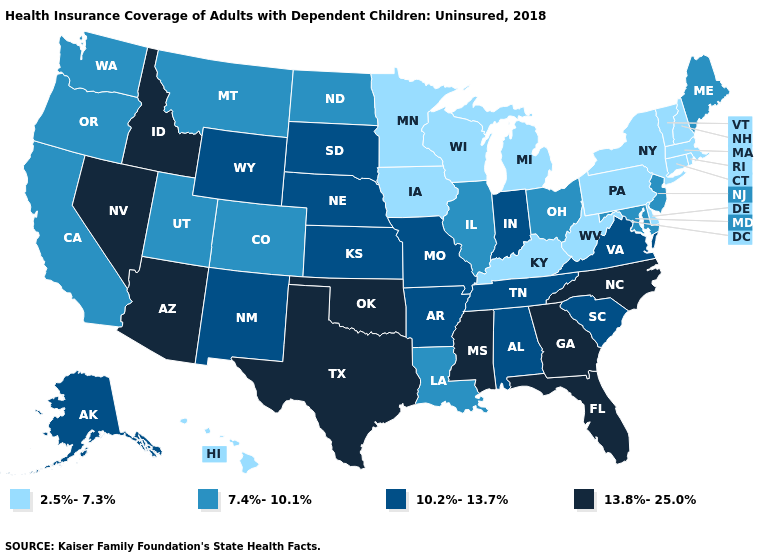Which states have the lowest value in the USA?
Write a very short answer. Connecticut, Delaware, Hawaii, Iowa, Kentucky, Massachusetts, Michigan, Minnesota, New Hampshire, New York, Pennsylvania, Rhode Island, Vermont, West Virginia, Wisconsin. Among the states that border Vermont , which have the highest value?
Be succinct. Massachusetts, New Hampshire, New York. What is the value of Idaho?
Keep it brief. 13.8%-25.0%. What is the value of Maryland?
Write a very short answer. 7.4%-10.1%. Does Rhode Island have the highest value in the Northeast?
Answer briefly. No. Name the states that have a value in the range 13.8%-25.0%?
Keep it brief. Arizona, Florida, Georgia, Idaho, Mississippi, Nevada, North Carolina, Oklahoma, Texas. Does Arizona have the highest value in the USA?
Answer briefly. Yes. Name the states that have a value in the range 13.8%-25.0%?
Answer briefly. Arizona, Florida, Georgia, Idaho, Mississippi, Nevada, North Carolina, Oklahoma, Texas. Does Nebraska have the lowest value in the USA?
Answer briefly. No. What is the value of Michigan?
Answer briefly. 2.5%-7.3%. Does Kentucky have the lowest value in the USA?
Be succinct. Yes. What is the value of Tennessee?
Write a very short answer. 10.2%-13.7%. What is the value of Indiana?
Give a very brief answer. 10.2%-13.7%. Name the states that have a value in the range 10.2%-13.7%?
Be succinct. Alabama, Alaska, Arkansas, Indiana, Kansas, Missouri, Nebraska, New Mexico, South Carolina, South Dakota, Tennessee, Virginia, Wyoming. Does Illinois have the lowest value in the MidWest?
Quick response, please. No. 